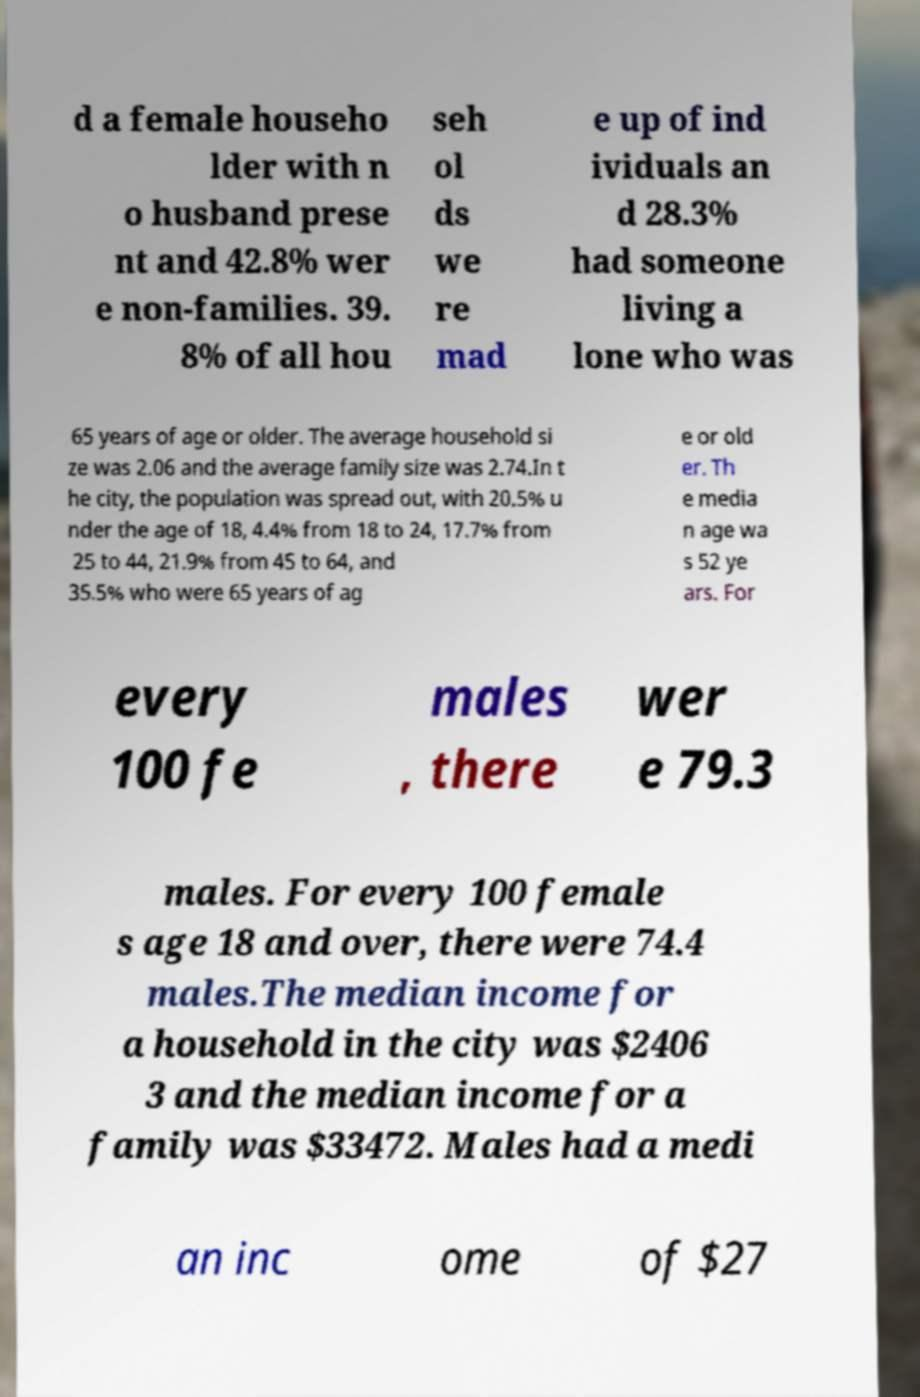Could you extract and type out the text from this image? d a female househo lder with n o husband prese nt and 42.8% wer e non-families. 39. 8% of all hou seh ol ds we re mad e up of ind ividuals an d 28.3% had someone living a lone who was 65 years of age or older. The average household si ze was 2.06 and the average family size was 2.74.In t he city, the population was spread out, with 20.5% u nder the age of 18, 4.4% from 18 to 24, 17.7% from 25 to 44, 21.9% from 45 to 64, and 35.5% who were 65 years of ag e or old er. Th e media n age wa s 52 ye ars. For every 100 fe males , there wer e 79.3 males. For every 100 female s age 18 and over, there were 74.4 males.The median income for a household in the city was $2406 3 and the median income for a family was $33472. Males had a medi an inc ome of $27 